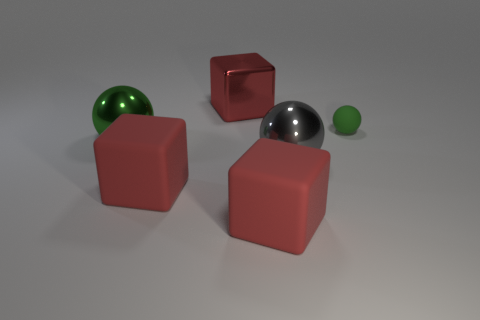What is the shape of the red thing behind the big gray metal ball?
Make the answer very short. Cube. Is the number of red matte objects that are behind the big gray object the same as the number of gray things to the right of the big metallic block?
Your answer should be compact. No. How many things are big gray shiny balls or red cubes that are in front of the small matte ball?
Your answer should be very brief. 3. There is a metallic thing that is both in front of the rubber sphere and on the left side of the gray ball; what is its shape?
Give a very brief answer. Sphere. There is a red block that is on the left side of the red block behind the green rubber sphere; what is it made of?
Provide a succinct answer. Rubber. Is the material of the green thing on the left side of the red shiny block the same as the gray sphere?
Provide a short and direct response. Yes. There is a rubber thing behind the large gray sphere; what size is it?
Provide a succinct answer. Small. Are there any big gray spheres on the right side of the metal thing in front of the big green ball?
Make the answer very short. No. Does the shiny thing that is behind the tiny matte sphere have the same color as the big sphere that is left of the large gray object?
Ensure brevity in your answer.  No. What color is the rubber ball?
Ensure brevity in your answer.  Green. 